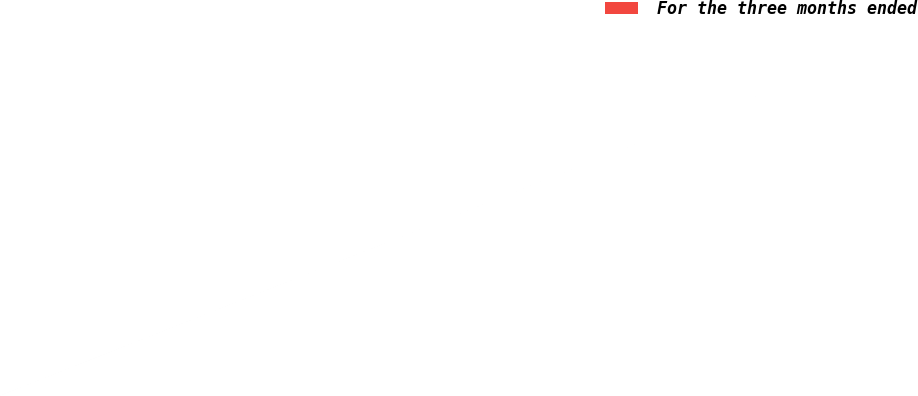Convert chart to OTSL. <chart><loc_0><loc_0><loc_500><loc_500><pie_chart><fcel>For the three months ended<nl><fcel>100.0%<nl></chart> 